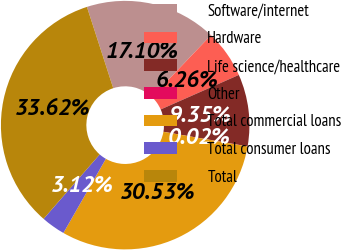Convert chart. <chart><loc_0><loc_0><loc_500><loc_500><pie_chart><fcel>Software/internet<fcel>Hardware<fcel>Life science/healthcare<fcel>Other<fcel>Total commercial loans<fcel>Total consumer loans<fcel>Total<nl><fcel>17.1%<fcel>6.26%<fcel>9.35%<fcel>0.02%<fcel>30.53%<fcel>3.12%<fcel>33.62%<nl></chart> 